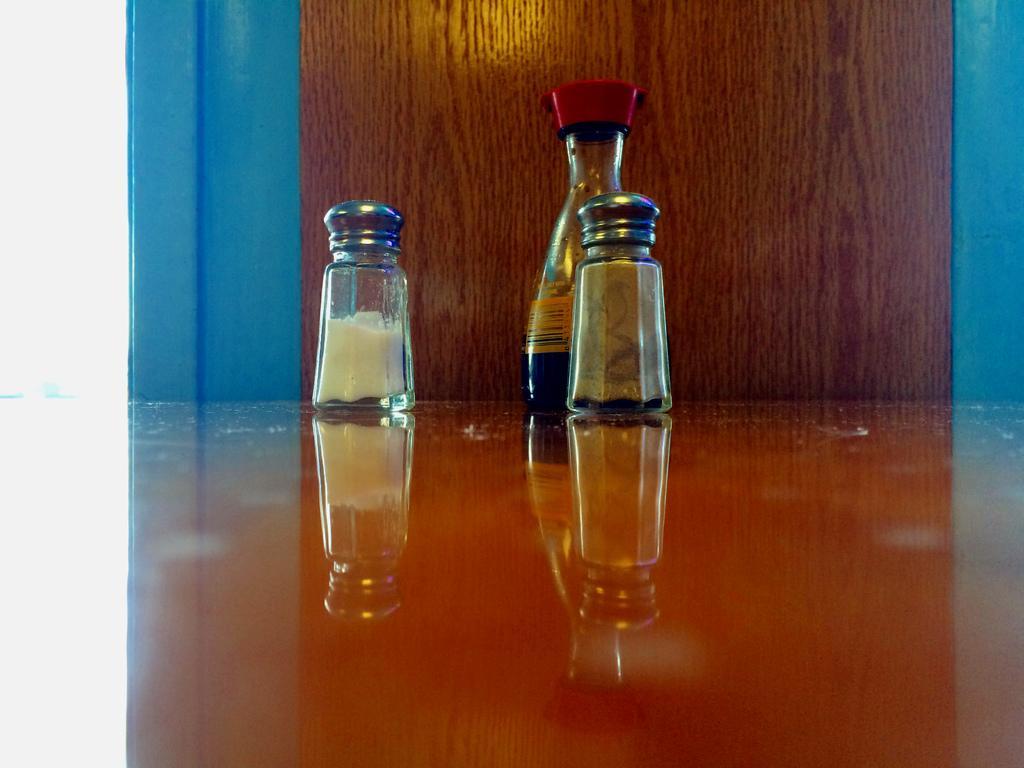Can you describe this image briefly? There are 3 small bottles here. 